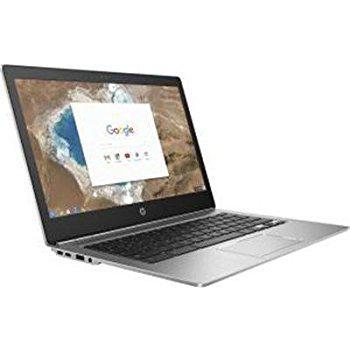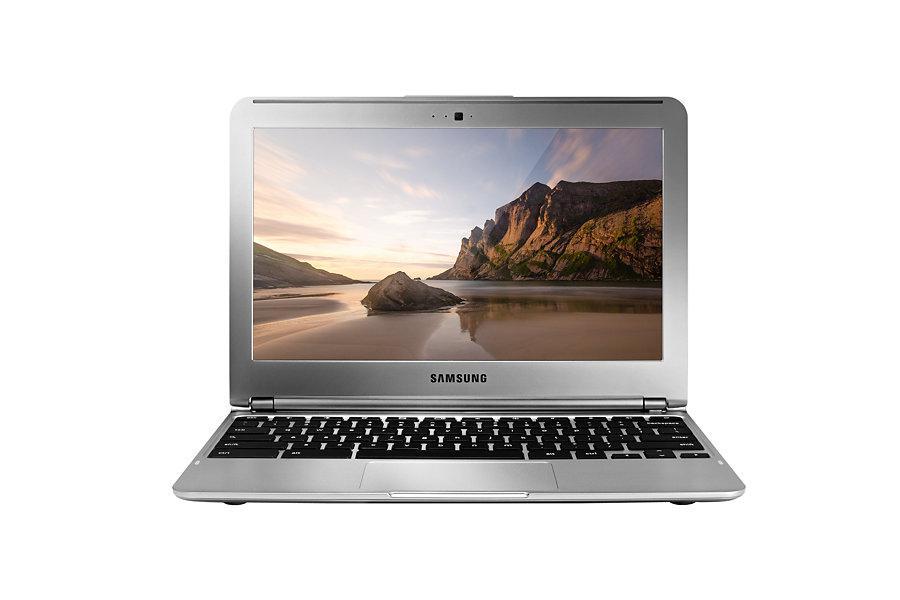The first image is the image on the left, the second image is the image on the right. For the images displayed, is the sentence "Each image shows one laptop open to at least 90-degrees and displaying a landscape with sky, and the laptops on the left and right face the same general direction." factually correct? Answer yes or no. No. The first image is the image on the left, the second image is the image on the right. For the images displayed, is the sentence "In at least one image there is a laptop facing front right with a white box on the screen." factually correct? Answer yes or no. Yes. 